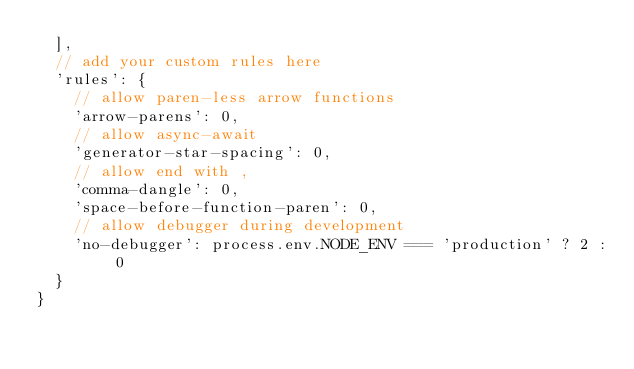<code> <loc_0><loc_0><loc_500><loc_500><_JavaScript_>  ],
  // add your custom rules here
  'rules': {
    // allow paren-less arrow functions
    'arrow-parens': 0,
    // allow async-await
    'generator-star-spacing': 0,
    // allow end with ,
    'comma-dangle': 0,
    'space-before-function-paren': 0,
    // allow debugger during development
    'no-debugger': process.env.NODE_ENV === 'production' ? 2 : 0
  }
}
</code> 